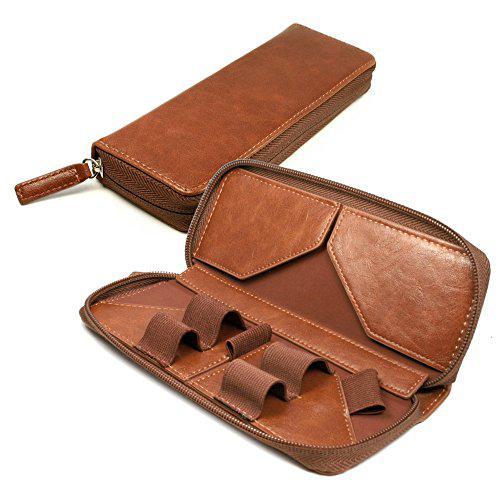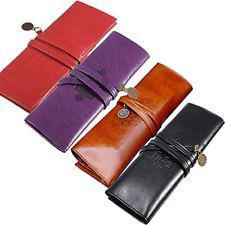The first image is the image on the left, the second image is the image on the right. Analyze the images presented: Is the assertion "An image shows one leather pencil case, displayed open with writing implements tucked inside." valid? Answer yes or no. No. The first image is the image on the left, the second image is the image on the right. For the images shown, is this caption "In one image, a leather pencil case is displayed closed in at least four colors, while the other image displays how a different brown case looks when opened." true? Answer yes or no. Yes. 